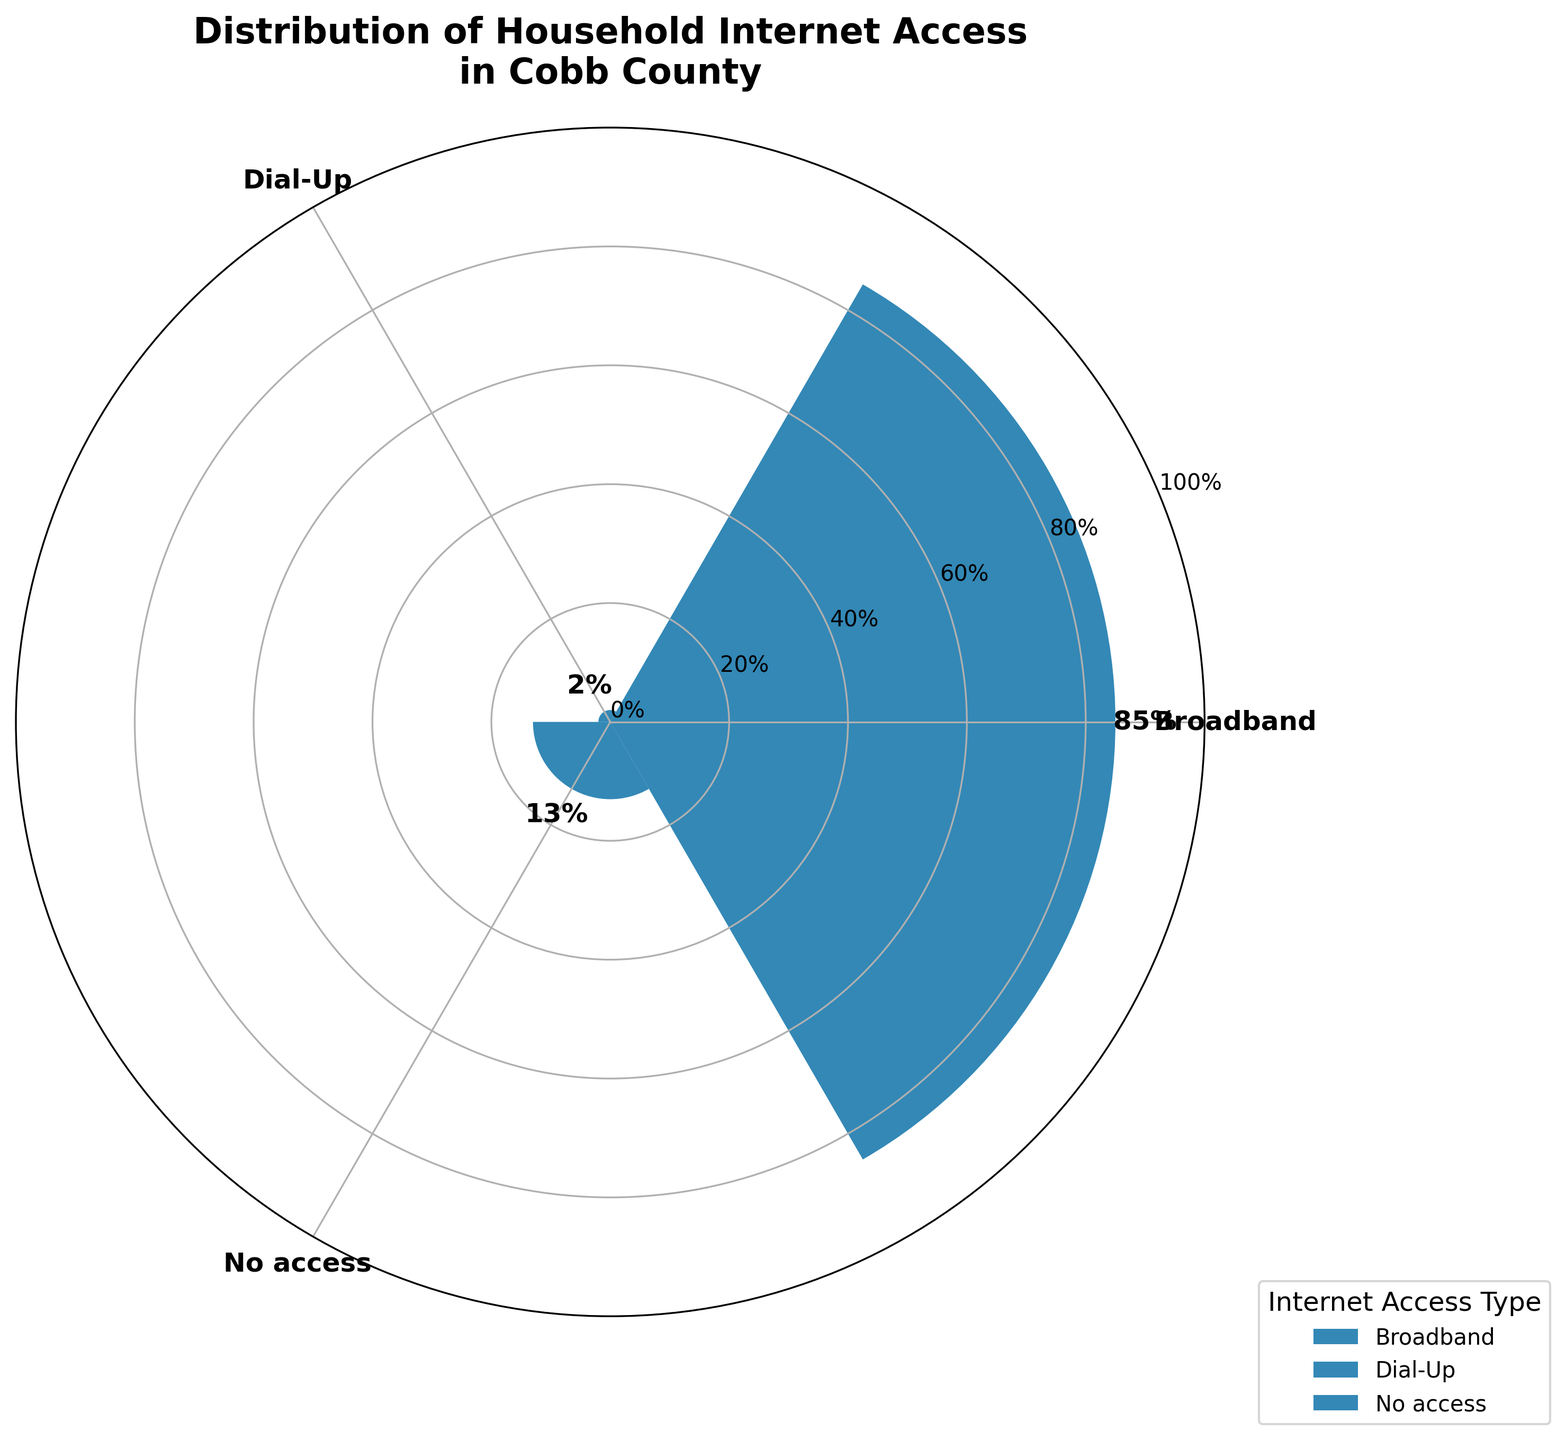what is the title of the chart? The title of the chart is placed at the top and it reads: "Distribution of Household Internet Access in Cobb County"
Answer: Distribution of Household Internet Access in Cobb County What percentage of households in Cobb County have Broadband access? The graph lists 85% for Broadband access, visible above the bar labeled "Broadband" in the rose chart.
Answer: 85% What is the least common type of internet access in Cobb County households? The segment with the lowest percentage is labeled "Dial-Up" and has 2%, which is the least among the groups.
Answer: Dial-Up How does the percentage of households with No Access compare to those with Dial-Up? The percentage of households with No Access (13%) is greater than those with Dial-Up (2%). The difference of 13% - 2% is 11%.
Answer: No Access is 11% greater than Dial-Up What is the combined percentage of households with either Dial-Up or No Access to the internet? To find the combined percentage, we add the percentages for Dial-Up (2%) and No Access (13%). 2% + 13% = 15%.
Answer: 15% Based on the chart, which internet access type has the second highest percentage? The second highest percentage after Broadband (85%) is No Access (13%), as it is greater than Dial-Up (2%).
Answer: No Access Which type of internet access is most common in Cobb County households? The largest bar segment is labeled "Broadband," indicating that 85% of households have broadband access, the highest among the types.
Answer: Broadband What is the difference in percentage between households with Broadband and those with No Access? The difference is calculated by subtracting the No Access percentage (13%) from the Broadband percentage (85%). 85% - 13% = 72%.
Answer: 72% How much more common is Broadband access compared to Dial-Up in Cobb County? The percentage of households with Broadband (85%) minus the percentage with Dial-Up (2%) is 83%, showing Broadband is 83% more common.
Answer: 83% If another internet access type accounted for the remaining percentage, what would it be? The total percentage must add up to 100%. Currently, Broadband (85%) + Dial-Up (2%) + No Access (13%) = 100%, so no percentage remains, hence no other type exists.
Answer: 0% 